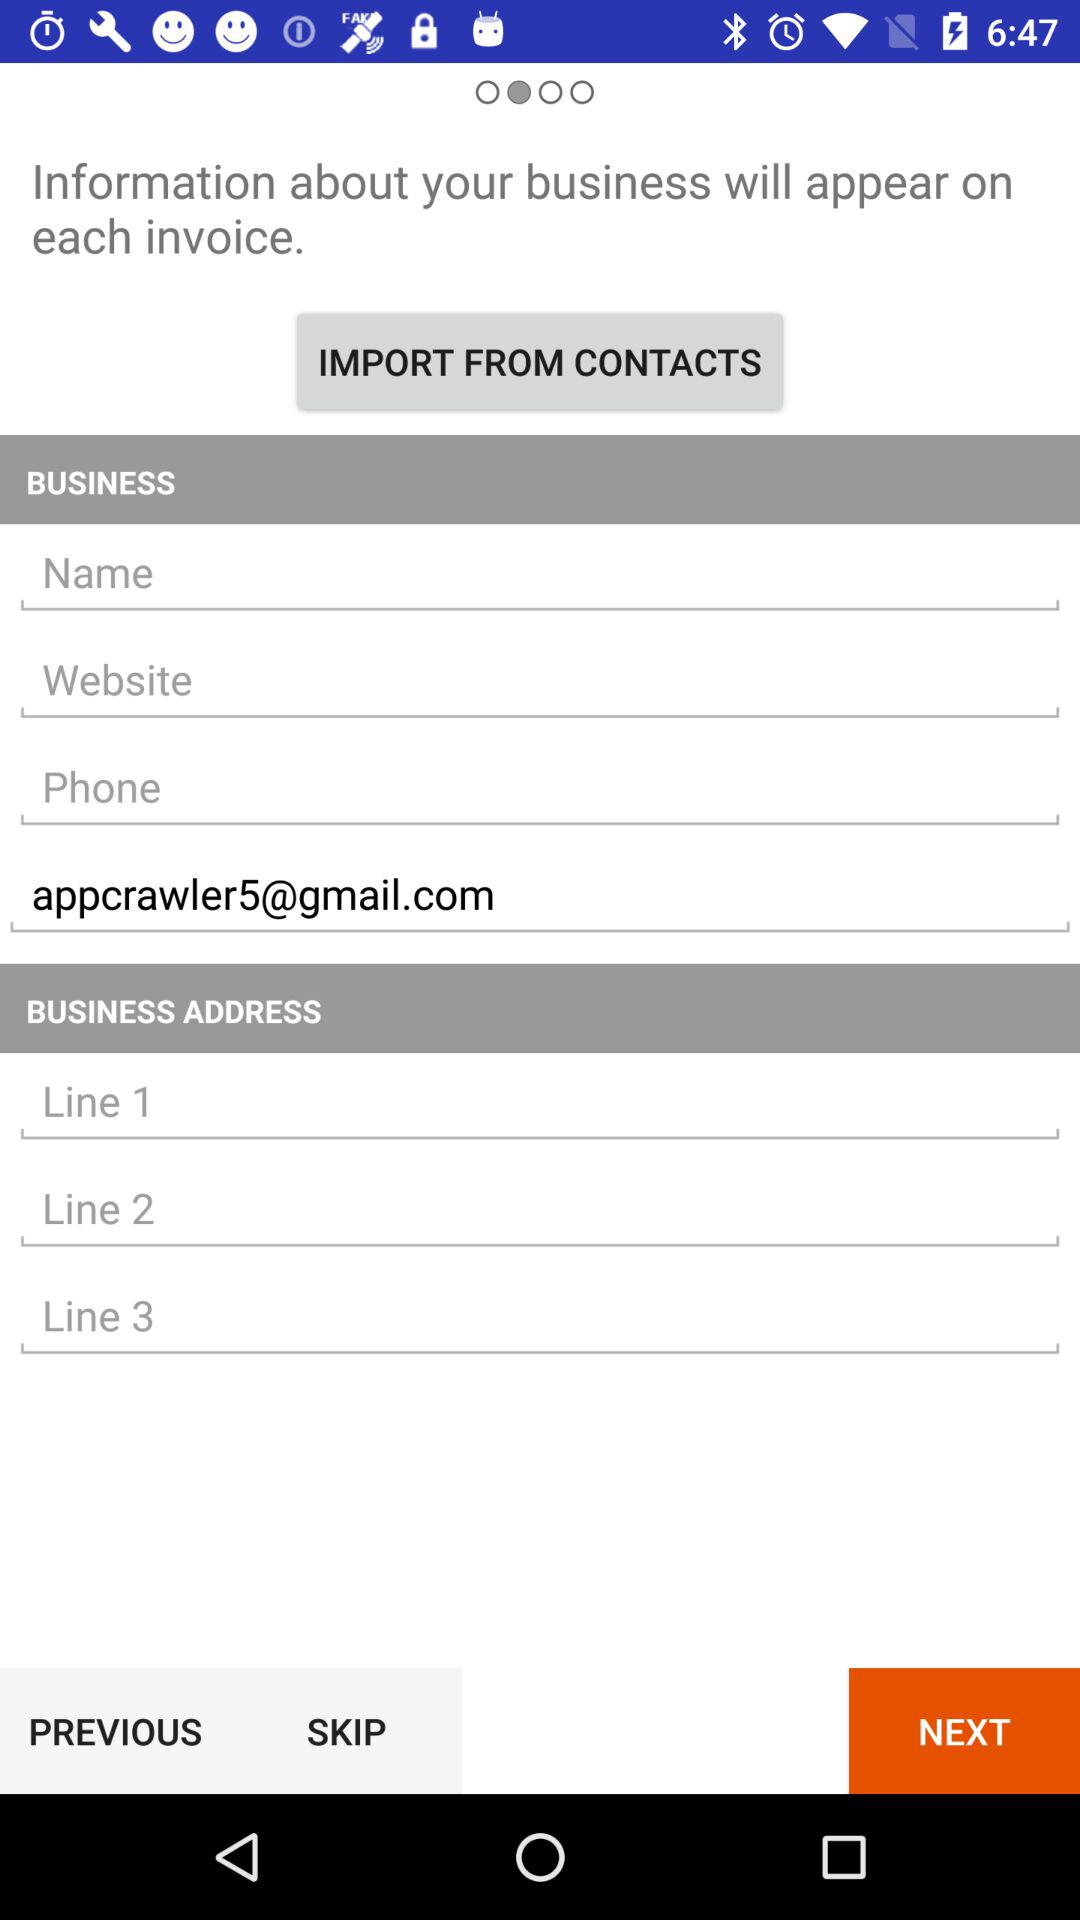How many input fields are there for the business address?
Answer the question using a single word or phrase. 3 